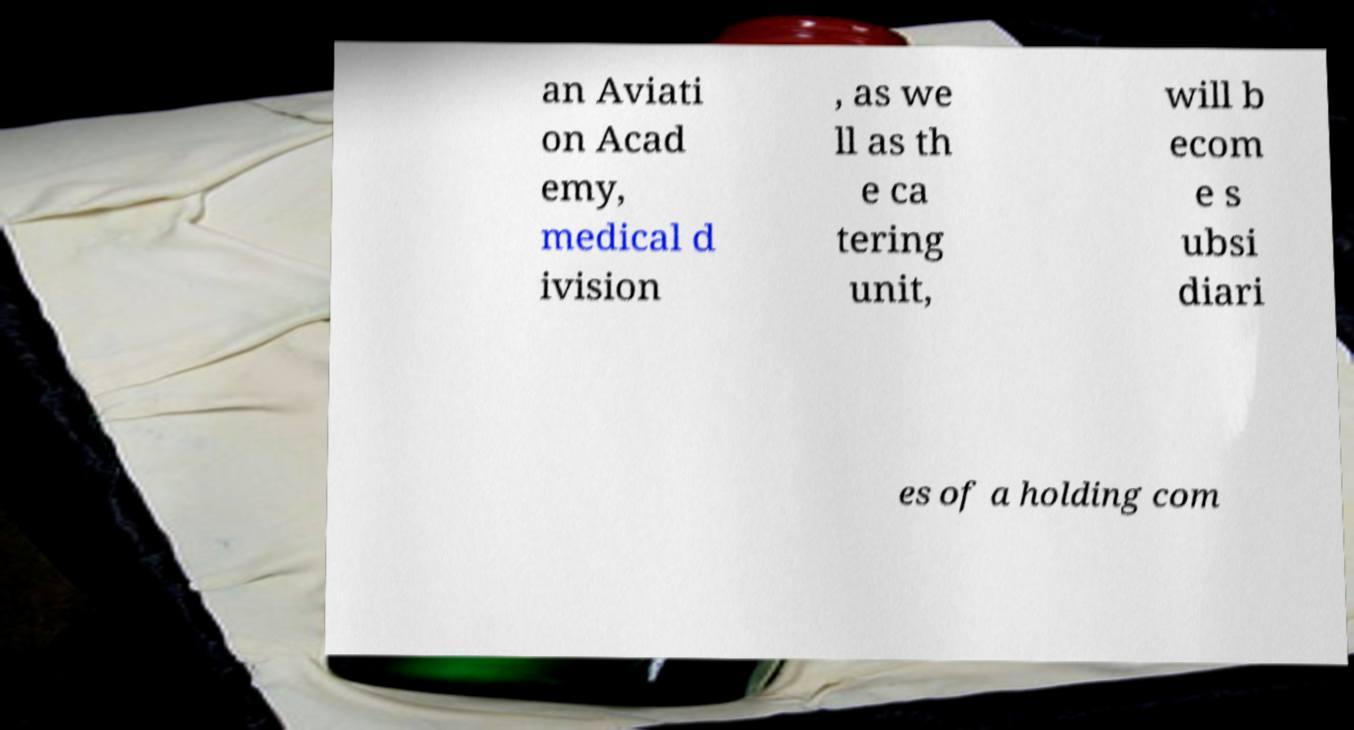I need the written content from this picture converted into text. Can you do that? an Aviati on Acad emy, medical d ivision , as we ll as th e ca tering unit, will b ecom e s ubsi diari es of a holding com 